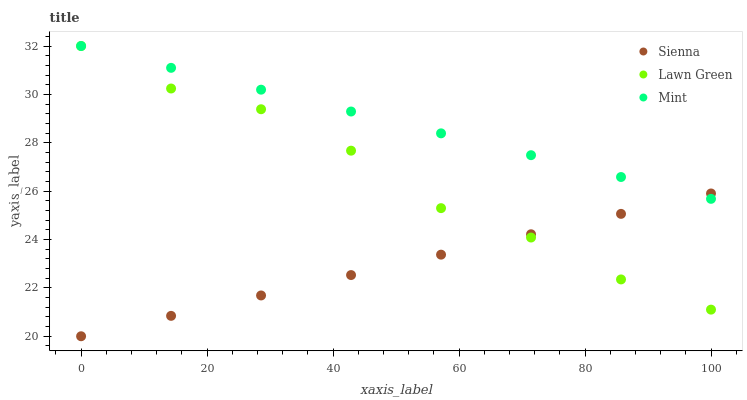Does Sienna have the minimum area under the curve?
Answer yes or no. Yes. Does Mint have the maximum area under the curve?
Answer yes or no. Yes. Does Lawn Green have the minimum area under the curve?
Answer yes or no. No. Does Lawn Green have the maximum area under the curve?
Answer yes or no. No. Is Sienna the smoothest?
Answer yes or no. Yes. Is Lawn Green the roughest?
Answer yes or no. Yes. Is Mint the smoothest?
Answer yes or no. No. Is Mint the roughest?
Answer yes or no. No. Does Sienna have the lowest value?
Answer yes or no. Yes. Does Lawn Green have the lowest value?
Answer yes or no. No. Does Mint have the highest value?
Answer yes or no. Yes. Does Sienna intersect Lawn Green?
Answer yes or no. Yes. Is Sienna less than Lawn Green?
Answer yes or no. No. Is Sienna greater than Lawn Green?
Answer yes or no. No. 